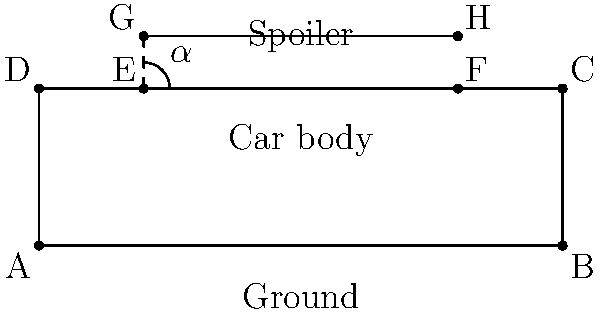As a car magazine editor, you're analyzing the aerodynamic profile of a new supercar. The rear spoiler is crucial for downforce generation. If the spoiler is 6 meters wide and elevated 1 meter above the car's body at an angle $\alpha$ to the horizontal, what is the angle $\alpha$ in degrees? Round your answer to the nearest whole number. To solve this problem, we'll use basic trigonometry:

1) First, let's identify the relevant triangle. We have a right-angled triangle formed by the spoiler, its height above the car body, and half of the spoiler's width.

2) The height of the triangle is 1 meter (the elevation of the spoiler).

3) Half of the spoiler's width is 3 meters (total width is 6 meters, so half is 3 meters).

4) We can use the arctangent function to find the angle. In this case:

   $\tan(\alpha) = \frac{\text{opposite}}{\text{adjacent}} = \frac{\text{height}}{\text{half width}} = \frac{1}{3}$

5) Therefore:

   $\alpha = \arctan(\frac{1}{3})$

6) Using a calculator or computer:

   $\alpha \approx 18.43494882292201$ degrees

7) Rounding to the nearest whole number:

   $\alpha \approx 18$ degrees
Answer: 18 degrees 